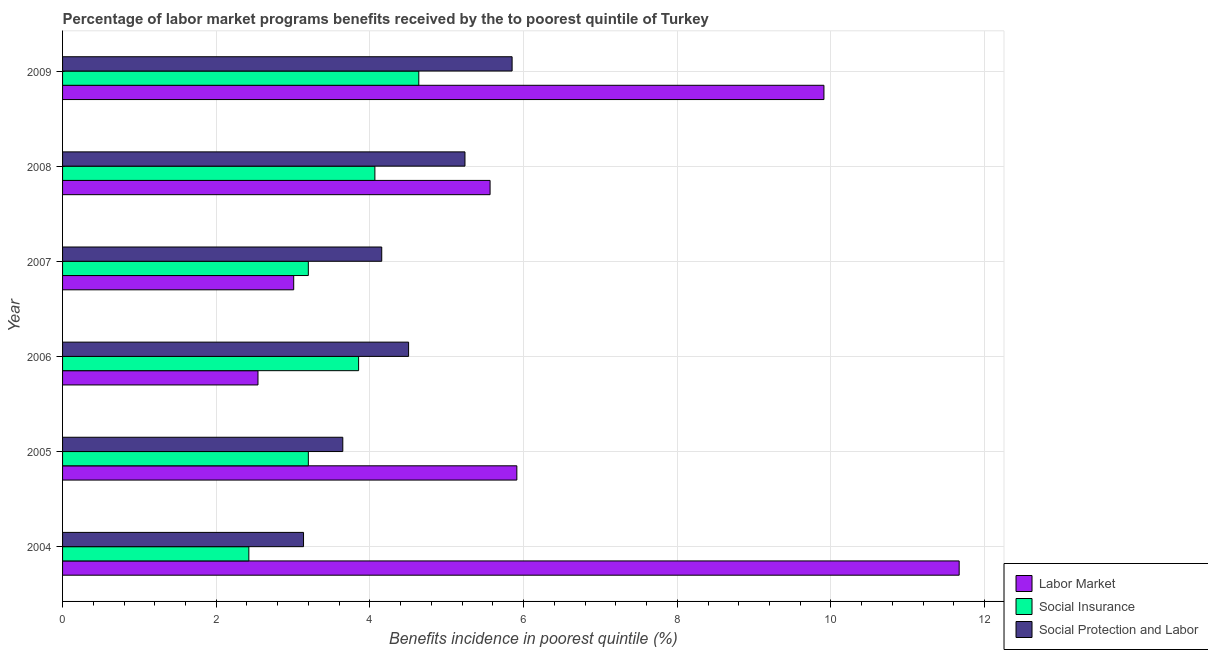How many different coloured bars are there?
Provide a succinct answer. 3. How many groups of bars are there?
Your response must be concise. 6. Are the number of bars per tick equal to the number of legend labels?
Your answer should be compact. Yes. Are the number of bars on each tick of the Y-axis equal?
Provide a short and direct response. Yes. How many bars are there on the 2nd tick from the top?
Keep it short and to the point. 3. How many bars are there on the 4th tick from the bottom?
Your answer should be compact. 3. What is the percentage of benefits received due to social protection programs in 2007?
Give a very brief answer. 4.15. Across all years, what is the maximum percentage of benefits received due to social protection programs?
Your answer should be very brief. 5.85. Across all years, what is the minimum percentage of benefits received due to social protection programs?
Ensure brevity in your answer.  3.14. In which year was the percentage of benefits received due to labor market programs minimum?
Provide a succinct answer. 2006. What is the total percentage of benefits received due to labor market programs in the graph?
Keep it short and to the point. 38.6. What is the difference between the percentage of benefits received due to social insurance programs in 2005 and that in 2008?
Keep it short and to the point. -0.87. What is the difference between the percentage of benefits received due to labor market programs in 2007 and the percentage of benefits received due to social insurance programs in 2004?
Ensure brevity in your answer.  0.58. What is the average percentage of benefits received due to social protection programs per year?
Your answer should be compact. 4.42. In the year 2008, what is the difference between the percentage of benefits received due to social insurance programs and percentage of benefits received due to social protection programs?
Your answer should be compact. -1.17. In how many years, is the percentage of benefits received due to social insurance programs greater than 8.4 %?
Provide a succinct answer. 0. What is the ratio of the percentage of benefits received due to labor market programs in 2007 to that in 2008?
Provide a succinct answer. 0.54. Is the percentage of benefits received due to social insurance programs in 2007 less than that in 2009?
Offer a very short reply. Yes. What is the difference between the highest and the second highest percentage of benefits received due to social protection programs?
Offer a terse response. 0.61. What is the difference between the highest and the lowest percentage of benefits received due to labor market programs?
Offer a very short reply. 9.13. What does the 2nd bar from the top in 2004 represents?
Your answer should be compact. Social Insurance. What does the 1st bar from the bottom in 2005 represents?
Keep it short and to the point. Labor Market. Is it the case that in every year, the sum of the percentage of benefits received due to labor market programs and percentage of benefits received due to social insurance programs is greater than the percentage of benefits received due to social protection programs?
Offer a terse response. Yes. What is the difference between two consecutive major ticks on the X-axis?
Give a very brief answer. 2. Are the values on the major ticks of X-axis written in scientific E-notation?
Keep it short and to the point. No. Does the graph contain grids?
Provide a succinct answer. Yes. Where does the legend appear in the graph?
Make the answer very short. Bottom right. How many legend labels are there?
Your answer should be compact. 3. How are the legend labels stacked?
Make the answer very short. Vertical. What is the title of the graph?
Offer a very short reply. Percentage of labor market programs benefits received by the to poorest quintile of Turkey. What is the label or title of the X-axis?
Keep it short and to the point. Benefits incidence in poorest quintile (%). What is the Benefits incidence in poorest quintile (%) in Labor Market in 2004?
Provide a succinct answer. 11.67. What is the Benefits incidence in poorest quintile (%) in Social Insurance in 2004?
Ensure brevity in your answer.  2.42. What is the Benefits incidence in poorest quintile (%) in Social Protection and Labor in 2004?
Your answer should be very brief. 3.14. What is the Benefits incidence in poorest quintile (%) in Labor Market in 2005?
Offer a very short reply. 5.91. What is the Benefits incidence in poorest quintile (%) of Social Insurance in 2005?
Make the answer very short. 3.2. What is the Benefits incidence in poorest quintile (%) of Social Protection and Labor in 2005?
Keep it short and to the point. 3.65. What is the Benefits incidence in poorest quintile (%) in Labor Market in 2006?
Give a very brief answer. 2.54. What is the Benefits incidence in poorest quintile (%) in Social Insurance in 2006?
Offer a terse response. 3.85. What is the Benefits incidence in poorest quintile (%) in Social Protection and Labor in 2006?
Make the answer very short. 4.5. What is the Benefits incidence in poorest quintile (%) of Labor Market in 2007?
Provide a succinct answer. 3.01. What is the Benefits incidence in poorest quintile (%) in Social Insurance in 2007?
Ensure brevity in your answer.  3.2. What is the Benefits incidence in poorest quintile (%) in Social Protection and Labor in 2007?
Provide a succinct answer. 4.15. What is the Benefits incidence in poorest quintile (%) of Labor Market in 2008?
Provide a short and direct response. 5.56. What is the Benefits incidence in poorest quintile (%) of Social Insurance in 2008?
Make the answer very short. 4.06. What is the Benefits incidence in poorest quintile (%) in Social Protection and Labor in 2008?
Your response must be concise. 5.24. What is the Benefits incidence in poorest quintile (%) in Labor Market in 2009?
Ensure brevity in your answer.  9.91. What is the Benefits incidence in poorest quintile (%) of Social Insurance in 2009?
Offer a very short reply. 4.64. What is the Benefits incidence in poorest quintile (%) in Social Protection and Labor in 2009?
Ensure brevity in your answer.  5.85. Across all years, what is the maximum Benefits incidence in poorest quintile (%) in Labor Market?
Your response must be concise. 11.67. Across all years, what is the maximum Benefits incidence in poorest quintile (%) in Social Insurance?
Provide a succinct answer. 4.64. Across all years, what is the maximum Benefits incidence in poorest quintile (%) of Social Protection and Labor?
Make the answer very short. 5.85. Across all years, what is the minimum Benefits incidence in poorest quintile (%) in Labor Market?
Provide a succinct answer. 2.54. Across all years, what is the minimum Benefits incidence in poorest quintile (%) of Social Insurance?
Your answer should be very brief. 2.42. Across all years, what is the minimum Benefits incidence in poorest quintile (%) in Social Protection and Labor?
Ensure brevity in your answer.  3.14. What is the total Benefits incidence in poorest quintile (%) of Labor Market in the graph?
Your answer should be compact. 38.6. What is the total Benefits incidence in poorest quintile (%) in Social Insurance in the graph?
Ensure brevity in your answer.  21.37. What is the total Benefits incidence in poorest quintile (%) in Social Protection and Labor in the graph?
Your answer should be compact. 26.53. What is the difference between the Benefits incidence in poorest quintile (%) in Labor Market in 2004 and that in 2005?
Offer a terse response. 5.76. What is the difference between the Benefits incidence in poorest quintile (%) in Social Insurance in 2004 and that in 2005?
Provide a succinct answer. -0.77. What is the difference between the Benefits incidence in poorest quintile (%) of Social Protection and Labor in 2004 and that in 2005?
Provide a short and direct response. -0.51. What is the difference between the Benefits incidence in poorest quintile (%) in Labor Market in 2004 and that in 2006?
Offer a very short reply. 9.13. What is the difference between the Benefits incidence in poorest quintile (%) in Social Insurance in 2004 and that in 2006?
Provide a succinct answer. -1.43. What is the difference between the Benefits incidence in poorest quintile (%) in Social Protection and Labor in 2004 and that in 2006?
Your response must be concise. -1.37. What is the difference between the Benefits incidence in poorest quintile (%) of Labor Market in 2004 and that in 2007?
Keep it short and to the point. 8.66. What is the difference between the Benefits incidence in poorest quintile (%) in Social Insurance in 2004 and that in 2007?
Your response must be concise. -0.77. What is the difference between the Benefits incidence in poorest quintile (%) of Social Protection and Labor in 2004 and that in 2007?
Give a very brief answer. -1.02. What is the difference between the Benefits incidence in poorest quintile (%) of Labor Market in 2004 and that in 2008?
Offer a terse response. 6.11. What is the difference between the Benefits incidence in poorest quintile (%) of Social Insurance in 2004 and that in 2008?
Offer a very short reply. -1.64. What is the difference between the Benefits incidence in poorest quintile (%) in Social Protection and Labor in 2004 and that in 2008?
Provide a short and direct response. -2.1. What is the difference between the Benefits incidence in poorest quintile (%) in Labor Market in 2004 and that in 2009?
Make the answer very short. 1.76. What is the difference between the Benefits incidence in poorest quintile (%) in Social Insurance in 2004 and that in 2009?
Provide a short and direct response. -2.21. What is the difference between the Benefits incidence in poorest quintile (%) of Social Protection and Labor in 2004 and that in 2009?
Your response must be concise. -2.71. What is the difference between the Benefits incidence in poorest quintile (%) in Labor Market in 2005 and that in 2006?
Give a very brief answer. 3.37. What is the difference between the Benefits incidence in poorest quintile (%) in Social Insurance in 2005 and that in 2006?
Ensure brevity in your answer.  -0.65. What is the difference between the Benefits incidence in poorest quintile (%) of Social Protection and Labor in 2005 and that in 2006?
Offer a very short reply. -0.86. What is the difference between the Benefits incidence in poorest quintile (%) of Labor Market in 2005 and that in 2007?
Offer a very short reply. 2.9. What is the difference between the Benefits incidence in poorest quintile (%) of Social Protection and Labor in 2005 and that in 2007?
Keep it short and to the point. -0.51. What is the difference between the Benefits incidence in poorest quintile (%) of Labor Market in 2005 and that in 2008?
Provide a succinct answer. 0.35. What is the difference between the Benefits incidence in poorest quintile (%) of Social Insurance in 2005 and that in 2008?
Ensure brevity in your answer.  -0.87. What is the difference between the Benefits incidence in poorest quintile (%) in Social Protection and Labor in 2005 and that in 2008?
Ensure brevity in your answer.  -1.59. What is the difference between the Benefits incidence in poorest quintile (%) in Labor Market in 2005 and that in 2009?
Your answer should be compact. -4. What is the difference between the Benefits incidence in poorest quintile (%) in Social Insurance in 2005 and that in 2009?
Ensure brevity in your answer.  -1.44. What is the difference between the Benefits incidence in poorest quintile (%) of Social Protection and Labor in 2005 and that in 2009?
Your answer should be compact. -2.2. What is the difference between the Benefits incidence in poorest quintile (%) of Labor Market in 2006 and that in 2007?
Your response must be concise. -0.46. What is the difference between the Benefits incidence in poorest quintile (%) of Social Insurance in 2006 and that in 2007?
Give a very brief answer. 0.65. What is the difference between the Benefits incidence in poorest quintile (%) in Social Protection and Labor in 2006 and that in 2007?
Your answer should be very brief. 0.35. What is the difference between the Benefits incidence in poorest quintile (%) of Labor Market in 2006 and that in 2008?
Your answer should be compact. -3.02. What is the difference between the Benefits incidence in poorest quintile (%) in Social Insurance in 2006 and that in 2008?
Give a very brief answer. -0.21. What is the difference between the Benefits incidence in poorest quintile (%) in Social Protection and Labor in 2006 and that in 2008?
Give a very brief answer. -0.73. What is the difference between the Benefits incidence in poorest quintile (%) in Labor Market in 2006 and that in 2009?
Ensure brevity in your answer.  -7.37. What is the difference between the Benefits incidence in poorest quintile (%) in Social Insurance in 2006 and that in 2009?
Keep it short and to the point. -0.78. What is the difference between the Benefits incidence in poorest quintile (%) of Social Protection and Labor in 2006 and that in 2009?
Offer a very short reply. -1.35. What is the difference between the Benefits incidence in poorest quintile (%) in Labor Market in 2007 and that in 2008?
Give a very brief answer. -2.56. What is the difference between the Benefits incidence in poorest quintile (%) in Social Insurance in 2007 and that in 2008?
Your response must be concise. -0.87. What is the difference between the Benefits incidence in poorest quintile (%) in Social Protection and Labor in 2007 and that in 2008?
Provide a short and direct response. -1.08. What is the difference between the Benefits incidence in poorest quintile (%) in Labor Market in 2007 and that in 2009?
Offer a terse response. -6.9. What is the difference between the Benefits incidence in poorest quintile (%) in Social Insurance in 2007 and that in 2009?
Your answer should be compact. -1.44. What is the difference between the Benefits incidence in poorest quintile (%) in Social Protection and Labor in 2007 and that in 2009?
Provide a short and direct response. -1.7. What is the difference between the Benefits incidence in poorest quintile (%) of Labor Market in 2008 and that in 2009?
Your answer should be very brief. -4.34. What is the difference between the Benefits incidence in poorest quintile (%) in Social Insurance in 2008 and that in 2009?
Provide a succinct answer. -0.57. What is the difference between the Benefits incidence in poorest quintile (%) in Social Protection and Labor in 2008 and that in 2009?
Make the answer very short. -0.61. What is the difference between the Benefits incidence in poorest quintile (%) of Labor Market in 2004 and the Benefits incidence in poorest quintile (%) of Social Insurance in 2005?
Ensure brevity in your answer.  8.47. What is the difference between the Benefits incidence in poorest quintile (%) of Labor Market in 2004 and the Benefits incidence in poorest quintile (%) of Social Protection and Labor in 2005?
Ensure brevity in your answer.  8.02. What is the difference between the Benefits incidence in poorest quintile (%) in Social Insurance in 2004 and the Benefits incidence in poorest quintile (%) in Social Protection and Labor in 2005?
Your answer should be very brief. -1.22. What is the difference between the Benefits incidence in poorest quintile (%) of Labor Market in 2004 and the Benefits incidence in poorest quintile (%) of Social Insurance in 2006?
Offer a very short reply. 7.82. What is the difference between the Benefits incidence in poorest quintile (%) in Labor Market in 2004 and the Benefits incidence in poorest quintile (%) in Social Protection and Labor in 2006?
Provide a short and direct response. 7.17. What is the difference between the Benefits incidence in poorest quintile (%) in Social Insurance in 2004 and the Benefits incidence in poorest quintile (%) in Social Protection and Labor in 2006?
Keep it short and to the point. -2.08. What is the difference between the Benefits incidence in poorest quintile (%) in Labor Market in 2004 and the Benefits incidence in poorest quintile (%) in Social Insurance in 2007?
Offer a very short reply. 8.47. What is the difference between the Benefits incidence in poorest quintile (%) in Labor Market in 2004 and the Benefits incidence in poorest quintile (%) in Social Protection and Labor in 2007?
Provide a succinct answer. 7.51. What is the difference between the Benefits incidence in poorest quintile (%) of Social Insurance in 2004 and the Benefits incidence in poorest quintile (%) of Social Protection and Labor in 2007?
Your answer should be very brief. -1.73. What is the difference between the Benefits incidence in poorest quintile (%) in Labor Market in 2004 and the Benefits incidence in poorest quintile (%) in Social Insurance in 2008?
Keep it short and to the point. 7.6. What is the difference between the Benefits incidence in poorest quintile (%) of Labor Market in 2004 and the Benefits incidence in poorest quintile (%) of Social Protection and Labor in 2008?
Your answer should be compact. 6.43. What is the difference between the Benefits incidence in poorest quintile (%) in Social Insurance in 2004 and the Benefits incidence in poorest quintile (%) in Social Protection and Labor in 2008?
Keep it short and to the point. -2.81. What is the difference between the Benefits incidence in poorest quintile (%) of Labor Market in 2004 and the Benefits incidence in poorest quintile (%) of Social Insurance in 2009?
Make the answer very short. 7.03. What is the difference between the Benefits incidence in poorest quintile (%) in Labor Market in 2004 and the Benefits incidence in poorest quintile (%) in Social Protection and Labor in 2009?
Keep it short and to the point. 5.82. What is the difference between the Benefits incidence in poorest quintile (%) in Social Insurance in 2004 and the Benefits incidence in poorest quintile (%) in Social Protection and Labor in 2009?
Give a very brief answer. -3.43. What is the difference between the Benefits incidence in poorest quintile (%) in Labor Market in 2005 and the Benefits incidence in poorest quintile (%) in Social Insurance in 2006?
Give a very brief answer. 2.06. What is the difference between the Benefits incidence in poorest quintile (%) of Labor Market in 2005 and the Benefits incidence in poorest quintile (%) of Social Protection and Labor in 2006?
Offer a very short reply. 1.41. What is the difference between the Benefits incidence in poorest quintile (%) of Social Insurance in 2005 and the Benefits incidence in poorest quintile (%) of Social Protection and Labor in 2006?
Offer a terse response. -1.3. What is the difference between the Benefits incidence in poorest quintile (%) in Labor Market in 2005 and the Benefits incidence in poorest quintile (%) in Social Insurance in 2007?
Your response must be concise. 2.71. What is the difference between the Benefits incidence in poorest quintile (%) in Labor Market in 2005 and the Benefits incidence in poorest quintile (%) in Social Protection and Labor in 2007?
Offer a very short reply. 1.76. What is the difference between the Benefits incidence in poorest quintile (%) of Social Insurance in 2005 and the Benefits incidence in poorest quintile (%) of Social Protection and Labor in 2007?
Your response must be concise. -0.96. What is the difference between the Benefits incidence in poorest quintile (%) in Labor Market in 2005 and the Benefits incidence in poorest quintile (%) in Social Insurance in 2008?
Offer a very short reply. 1.85. What is the difference between the Benefits incidence in poorest quintile (%) of Labor Market in 2005 and the Benefits incidence in poorest quintile (%) of Social Protection and Labor in 2008?
Your answer should be very brief. 0.68. What is the difference between the Benefits incidence in poorest quintile (%) of Social Insurance in 2005 and the Benefits incidence in poorest quintile (%) of Social Protection and Labor in 2008?
Ensure brevity in your answer.  -2.04. What is the difference between the Benefits incidence in poorest quintile (%) in Labor Market in 2005 and the Benefits incidence in poorest quintile (%) in Social Insurance in 2009?
Provide a short and direct response. 1.28. What is the difference between the Benefits incidence in poorest quintile (%) of Labor Market in 2005 and the Benefits incidence in poorest quintile (%) of Social Protection and Labor in 2009?
Your answer should be very brief. 0.06. What is the difference between the Benefits incidence in poorest quintile (%) in Social Insurance in 2005 and the Benefits incidence in poorest quintile (%) in Social Protection and Labor in 2009?
Offer a terse response. -2.65. What is the difference between the Benefits incidence in poorest quintile (%) of Labor Market in 2006 and the Benefits incidence in poorest quintile (%) of Social Insurance in 2007?
Ensure brevity in your answer.  -0.66. What is the difference between the Benefits incidence in poorest quintile (%) of Labor Market in 2006 and the Benefits incidence in poorest quintile (%) of Social Protection and Labor in 2007?
Offer a very short reply. -1.61. What is the difference between the Benefits incidence in poorest quintile (%) of Social Insurance in 2006 and the Benefits incidence in poorest quintile (%) of Social Protection and Labor in 2007?
Offer a very short reply. -0.3. What is the difference between the Benefits incidence in poorest quintile (%) in Labor Market in 2006 and the Benefits incidence in poorest quintile (%) in Social Insurance in 2008?
Your answer should be compact. -1.52. What is the difference between the Benefits incidence in poorest quintile (%) of Labor Market in 2006 and the Benefits incidence in poorest quintile (%) of Social Protection and Labor in 2008?
Your answer should be very brief. -2.69. What is the difference between the Benefits incidence in poorest quintile (%) in Social Insurance in 2006 and the Benefits incidence in poorest quintile (%) in Social Protection and Labor in 2008?
Your response must be concise. -1.38. What is the difference between the Benefits incidence in poorest quintile (%) of Labor Market in 2006 and the Benefits incidence in poorest quintile (%) of Social Insurance in 2009?
Your answer should be compact. -2.09. What is the difference between the Benefits incidence in poorest quintile (%) in Labor Market in 2006 and the Benefits incidence in poorest quintile (%) in Social Protection and Labor in 2009?
Give a very brief answer. -3.31. What is the difference between the Benefits incidence in poorest quintile (%) in Social Insurance in 2006 and the Benefits incidence in poorest quintile (%) in Social Protection and Labor in 2009?
Your answer should be compact. -2. What is the difference between the Benefits incidence in poorest quintile (%) of Labor Market in 2007 and the Benefits incidence in poorest quintile (%) of Social Insurance in 2008?
Provide a short and direct response. -1.06. What is the difference between the Benefits incidence in poorest quintile (%) of Labor Market in 2007 and the Benefits incidence in poorest quintile (%) of Social Protection and Labor in 2008?
Keep it short and to the point. -2.23. What is the difference between the Benefits incidence in poorest quintile (%) in Social Insurance in 2007 and the Benefits incidence in poorest quintile (%) in Social Protection and Labor in 2008?
Your answer should be compact. -2.04. What is the difference between the Benefits incidence in poorest quintile (%) in Labor Market in 2007 and the Benefits incidence in poorest quintile (%) in Social Insurance in 2009?
Offer a terse response. -1.63. What is the difference between the Benefits incidence in poorest quintile (%) in Labor Market in 2007 and the Benefits incidence in poorest quintile (%) in Social Protection and Labor in 2009?
Ensure brevity in your answer.  -2.84. What is the difference between the Benefits incidence in poorest quintile (%) of Social Insurance in 2007 and the Benefits incidence in poorest quintile (%) of Social Protection and Labor in 2009?
Provide a succinct answer. -2.65. What is the difference between the Benefits incidence in poorest quintile (%) in Labor Market in 2008 and the Benefits incidence in poorest quintile (%) in Social Insurance in 2009?
Provide a succinct answer. 0.93. What is the difference between the Benefits incidence in poorest quintile (%) of Labor Market in 2008 and the Benefits incidence in poorest quintile (%) of Social Protection and Labor in 2009?
Make the answer very short. -0.29. What is the difference between the Benefits incidence in poorest quintile (%) in Social Insurance in 2008 and the Benefits incidence in poorest quintile (%) in Social Protection and Labor in 2009?
Your answer should be compact. -1.79. What is the average Benefits incidence in poorest quintile (%) in Labor Market per year?
Provide a succinct answer. 6.43. What is the average Benefits incidence in poorest quintile (%) in Social Insurance per year?
Provide a short and direct response. 3.56. What is the average Benefits incidence in poorest quintile (%) of Social Protection and Labor per year?
Provide a succinct answer. 4.42. In the year 2004, what is the difference between the Benefits incidence in poorest quintile (%) in Labor Market and Benefits incidence in poorest quintile (%) in Social Insurance?
Make the answer very short. 9.24. In the year 2004, what is the difference between the Benefits incidence in poorest quintile (%) in Labor Market and Benefits incidence in poorest quintile (%) in Social Protection and Labor?
Your answer should be very brief. 8.53. In the year 2004, what is the difference between the Benefits incidence in poorest quintile (%) in Social Insurance and Benefits incidence in poorest quintile (%) in Social Protection and Labor?
Provide a short and direct response. -0.71. In the year 2005, what is the difference between the Benefits incidence in poorest quintile (%) in Labor Market and Benefits incidence in poorest quintile (%) in Social Insurance?
Your answer should be very brief. 2.71. In the year 2005, what is the difference between the Benefits incidence in poorest quintile (%) in Labor Market and Benefits incidence in poorest quintile (%) in Social Protection and Labor?
Your answer should be very brief. 2.27. In the year 2005, what is the difference between the Benefits incidence in poorest quintile (%) of Social Insurance and Benefits incidence in poorest quintile (%) of Social Protection and Labor?
Ensure brevity in your answer.  -0.45. In the year 2006, what is the difference between the Benefits incidence in poorest quintile (%) in Labor Market and Benefits incidence in poorest quintile (%) in Social Insurance?
Make the answer very short. -1.31. In the year 2006, what is the difference between the Benefits incidence in poorest quintile (%) in Labor Market and Benefits incidence in poorest quintile (%) in Social Protection and Labor?
Provide a succinct answer. -1.96. In the year 2006, what is the difference between the Benefits incidence in poorest quintile (%) of Social Insurance and Benefits incidence in poorest quintile (%) of Social Protection and Labor?
Offer a terse response. -0.65. In the year 2007, what is the difference between the Benefits incidence in poorest quintile (%) in Labor Market and Benefits incidence in poorest quintile (%) in Social Insurance?
Provide a succinct answer. -0.19. In the year 2007, what is the difference between the Benefits incidence in poorest quintile (%) of Labor Market and Benefits incidence in poorest quintile (%) of Social Protection and Labor?
Offer a very short reply. -1.15. In the year 2007, what is the difference between the Benefits incidence in poorest quintile (%) in Social Insurance and Benefits incidence in poorest quintile (%) in Social Protection and Labor?
Your answer should be compact. -0.96. In the year 2008, what is the difference between the Benefits incidence in poorest quintile (%) in Labor Market and Benefits incidence in poorest quintile (%) in Social Insurance?
Make the answer very short. 1.5. In the year 2008, what is the difference between the Benefits incidence in poorest quintile (%) in Labor Market and Benefits incidence in poorest quintile (%) in Social Protection and Labor?
Your answer should be compact. 0.33. In the year 2008, what is the difference between the Benefits incidence in poorest quintile (%) of Social Insurance and Benefits incidence in poorest quintile (%) of Social Protection and Labor?
Give a very brief answer. -1.17. In the year 2009, what is the difference between the Benefits incidence in poorest quintile (%) of Labor Market and Benefits incidence in poorest quintile (%) of Social Insurance?
Offer a terse response. 5.27. In the year 2009, what is the difference between the Benefits incidence in poorest quintile (%) in Labor Market and Benefits incidence in poorest quintile (%) in Social Protection and Labor?
Your answer should be very brief. 4.06. In the year 2009, what is the difference between the Benefits incidence in poorest quintile (%) of Social Insurance and Benefits incidence in poorest quintile (%) of Social Protection and Labor?
Ensure brevity in your answer.  -1.21. What is the ratio of the Benefits incidence in poorest quintile (%) in Labor Market in 2004 to that in 2005?
Provide a short and direct response. 1.97. What is the ratio of the Benefits incidence in poorest quintile (%) in Social Insurance in 2004 to that in 2005?
Provide a short and direct response. 0.76. What is the ratio of the Benefits incidence in poorest quintile (%) in Social Protection and Labor in 2004 to that in 2005?
Your response must be concise. 0.86. What is the ratio of the Benefits incidence in poorest quintile (%) of Labor Market in 2004 to that in 2006?
Ensure brevity in your answer.  4.59. What is the ratio of the Benefits incidence in poorest quintile (%) of Social Insurance in 2004 to that in 2006?
Provide a succinct answer. 0.63. What is the ratio of the Benefits incidence in poorest quintile (%) of Social Protection and Labor in 2004 to that in 2006?
Ensure brevity in your answer.  0.7. What is the ratio of the Benefits incidence in poorest quintile (%) of Labor Market in 2004 to that in 2007?
Your answer should be compact. 3.88. What is the ratio of the Benefits incidence in poorest quintile (%) of Social Insurance in 2004 to that in 2007?
Keep it short and to the point. 0.76. What is the ratio of the Benefits incidence in poorest quintile (%) in Social Protection and Labor in 2004 to that in 2007?
Give a very brief answer. 0.76. What is the ratio of the Benefits incidence in poorest quintile (%) of Labor Market in 2004 to that in 2008?
Give a very brief answer. 2.1. What is the ratio of the Benefits incidence in poorest quintile (%) of Social Insurance in 2004 to that in 2008?
Provide a short and direct response. 0.6. What is the ratio of the Benefits incidence in poorest quintile (%) in Social Protection and Labor in 2004 to that in 2008?
Offer a very short reply. 0.6. What is the ratio of the Benefits incidence in poorest quintile (%) in Labor Market in 2004 to that in 2009?
Give a very brief answer. 1.18. What is the ratio of the Benefits incidence in poorest quintile (%) in Social Insurance in 2004 to that in 2009?
Offer a very short reply. 0.52. What is the ratio of the Benefits incidence in poorest quintile (%) of Social Protection and Labor in 2004 to that in 2009?
Your answer should be very brief. 0.54. What is the ratio of the Benefits incidence in poorest quintile (%) of Labor Market in 2005 to that in 2006?
Offer a very short reply. 2.32. What is the ratio of the Benefits incidence in poorest quintile (%) in Social Insurance in 2005 to that in 2006?
Your answer should be very brief. 0.83. What is the ratio of the Benefits incidence in poorest quintile (%) of Social Protection and Labor in 2005 to that in 2006?
Your answer should be very brief. 0.81. What is the ratio of the Benefits incidence in poorest quintile (%) in Labor Market in 2005 to that in 2007?
Your answer should be compact. 1.97. What is the ratio of the Benefits incidence in poorest quintile (%) in Social Protection and Labor in 2005 to that in 2007?
Make the answer very short. 0.88. What is the ratio of the Benefits incidence in poorest quintile (%) in Labor Market in 2005 to that in 2008?
Make the answer very short. 1.06. What is the ratio of the Benefits incidence in poorest quintile (%) in Social Insurance in 2005 to that in 2008?
Keep it short and to the point. 0.79. What is the ratio of the Benefits incidence in poorest quintile (%) of Social Protection and Labor in 2005 to that in 2008?
Provide a short and direct response. 0.7. What is the ratio of the Benefits incidence in poorest quintile (%) of Labor Market in 2005 to that in 2009?
Give a very brief answer. 0.6. What is the ratio of the Benefits incidence in poorest quintile (%) of Social Insurance in 2005 to that in 2009?
Offer a very short reply. 0.69. What is the ratio of the Benefits incidence in poorest quintile (%) of Social Protection and Labor in 2005 to that in 2009?
Provide a succinct answer. 0.62. What is the ratio of the Benefits incidence in poorest quintile (%) in Labor Market in 2006 to that in 2007?
Keep it short and to the point. 0.85. What is the ratio of the Benefits incidence in poorest quintile (%) of Social Insurance in 2006 to that in 2007?
Ensure brevity in your answer.  1.2. What is the ratio of the Benefits incidence in poorest quintile (%) of Social Protection and Labor in 2006 to that in 2007?
Give a very brief answer. 1.08. What is the ratio of the Benefits incidence in poorest quintile (%) of Labor Market in 2006 to that in 2008?
Provide a short and direct response. 0.46. What is the ratio of the Benefits incidence in poorest quintile (%) of Social Insurance in 2006 to that in 2008?
Your response must be concise. 0.95. What is the ratio of the Benefits incidence in poorest quintile (%) of Social Protection and Labor in 2006 to that in 2008?
Offer a terse response. 0.86. What is the ratio of the Benefits incidence in poorest quintile (%) of Labor Market in 2006 to that in 2009?
Keep it short and to the point. 0.26. What is the ratio of the Benefits incidence in poorest quintile (%) in Social Insurance in 2006 to that in 2009?
Make the answer very short. 0.83. What is the ratio of the Benefits incidence in poorest quintile (%) in Social Protection and Labor in 2006 to that in 2009?
Keep it short and to the point. 0.77. What is the ratio of the Benefits incidence in poorest quintile (%) in Labor Market in 2007 to that in 2008?
Your response must be concise. 0.54. What is the ratio of the Benefits incidence in poorest quintile (%) of Social Insurance in 2007 to that in 2008?
Give a very brief answer. 0.79. What is the ratio of the Benefits incidence in poorest quintile (%) of Social Protection and Labor in 2007 to that in 2008?
Your answer should be compact. 0.79. What is the ratio of the Benefits incidence in poorest quintile (%) in Labor Market in 2007 to that in 2009?
Give a very brief answer. 0.3. What is the ratio of the Benefits incidence in poorest quintile (%) of Social Insurance in 2007 to that in 2009?
Your answer should be compact. 0.69. What is the ratio of the Benefits incidence in poorest quintile (%) in Social Protection and Labor in 2007 to that in 2009?
Provide a short and direct response. 0.71. What is the ratio of the Benefits incidence in poorest quintile (%) in Labor Market in 2008 to that in 2009?
Offer a terse response. 0.56. What is the ratio of the Benefits incidence in poorest quintile (%) of Social Insurance in 2008 to that in 2009?
Give a very brief answer. 0.88. What is the ratio of the Benefits incidence in poorest quintile (%) of Social Protection and Labor in 2008 to that in 2009?
Give a very brief answer. 0.9. What is the difference between the highest and the second highest Benefits incidence in poorest quintile (%) in Labor Market?
Your answer should be compact. 1.76. What is the difference between the highest and the second highest Benefits incidence in poorest quintile (%) in Social Insurance?
Keep it short and to the point. 0.57. What is the difference between the highest and the second highest Benefits incidence in poorest quintile (%) of Social Protection and Labor?
Provide a succinct answer. 0.61. What is the difference between the highest and the lowest Benefits incidence in poorest quintile (%) in Labor Market?
Ensure brevity in your answer.  9.13. What is the difference between the highest and the lowest Benefits incidence in poorest quintile (%) in Social Insurance?
Provide a short and direct response. 2.21. What is the difference between the highest and the lowest Benefits incidence in poorest quintile (%) in Social Protection and Labor?
Your answer should be very brief. 2.71. 